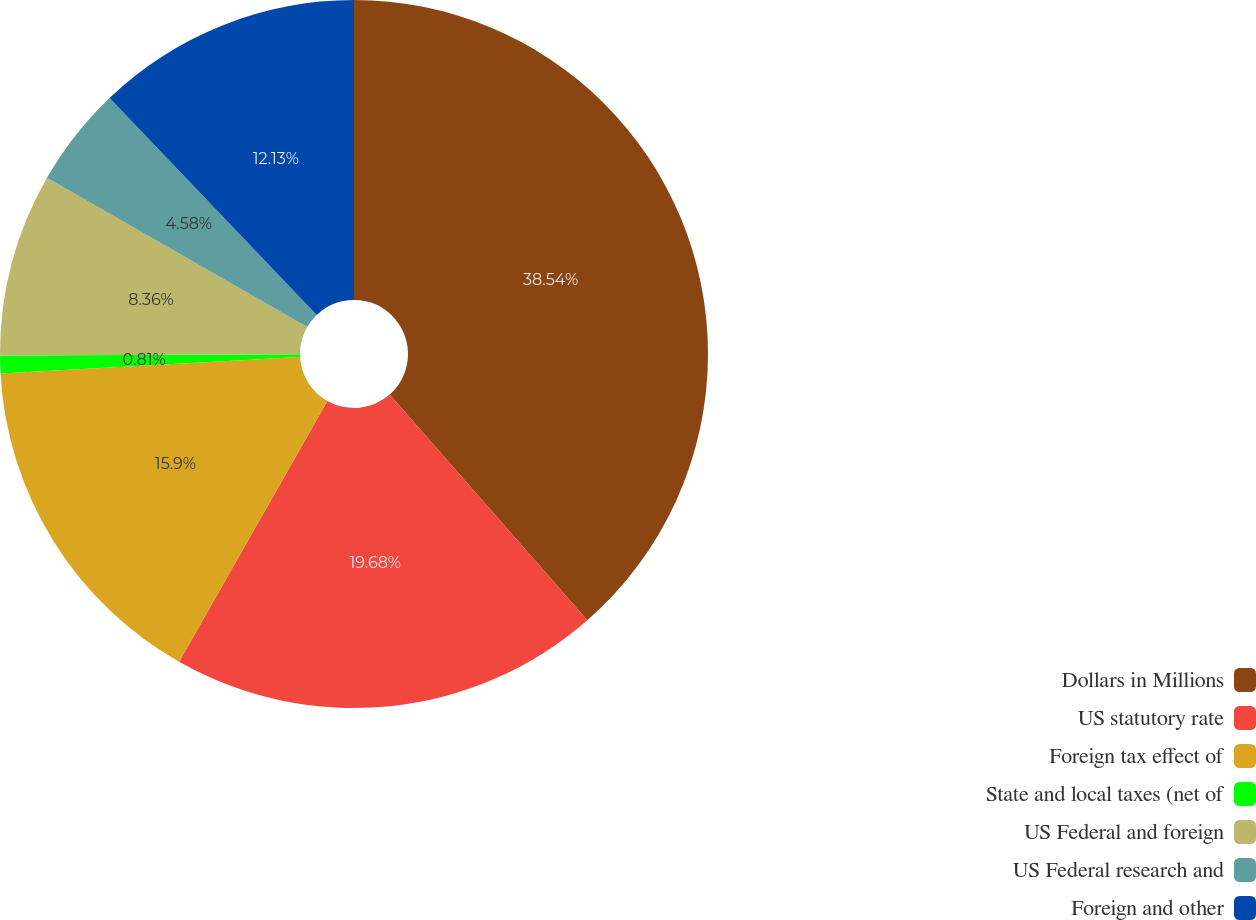Convert chart to OTSL. <chart><loc_0><loc_0><loc_500><loc_500><pie_chart><fcel>Dollars in Millions<fcel>US statutory rate<fcel>Foreign tax effect of<fcel>State and local taxes (net of<fcel>US Federal and foreign<fcel>US Federal research and<fcel>Foreign and other<nl><fcel>38.55%<fcel>19.68%<fcel>15.9%<fcel>0.81%<fcel>8.36%<fcel>4.58%<fcel>12.13%<nl></chart> 